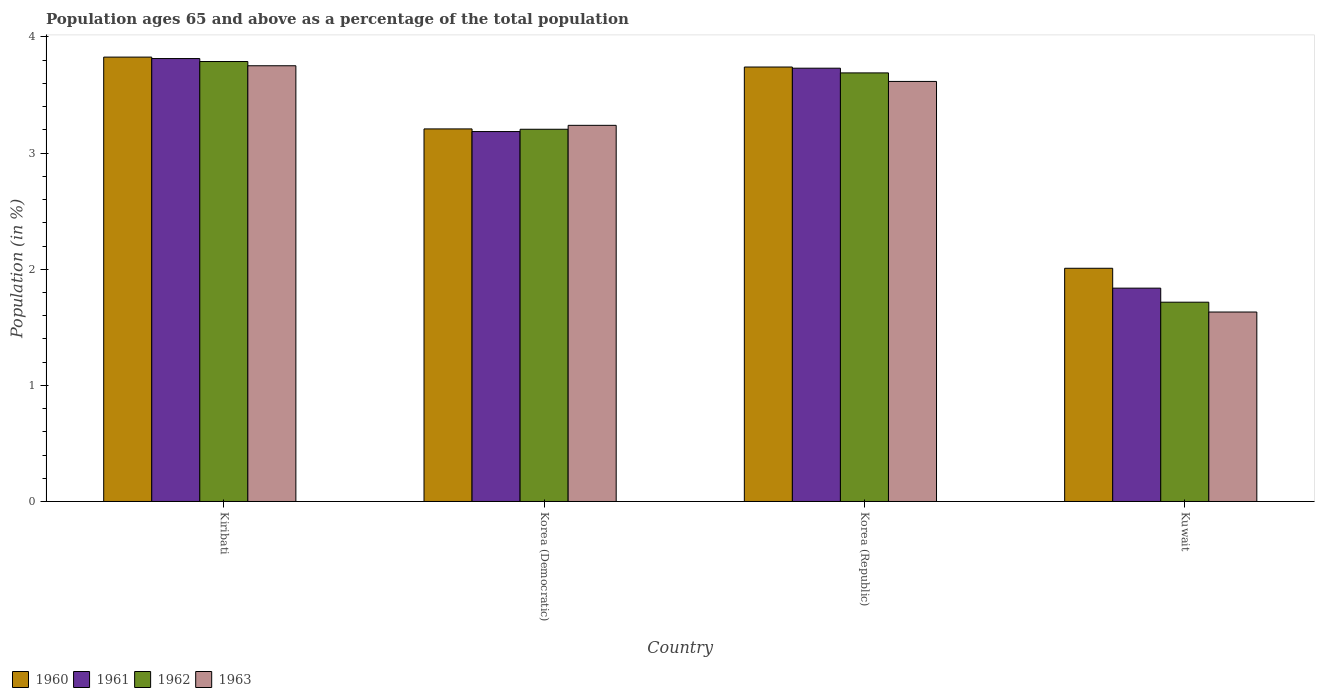How many groups of bars are there?
Ensure brevity in your answer.  4. Are the number of bars on each tick of the X-axis equal?
Ensure brevity in your answer.  Yes. How many bars are there on the 4th tick from the left?
Ensure brevity in your answer.  4. What is the label of the 2nd group of bars from the left?
Make the answer very short. Korea (Democratic). What is the percentage of the population ages 65 and above in 1963 in Korea (Democratic)?
Make the answer very short. 3.24. Across all countries, what is the maximum percentage of the population ages 65 and above in 1963?
Ensure brevity in your answer.  3.75. Across all countries, what is the minimum percentage of the population ages 65 and above in 1961?
Give a very brief answer. 1.84. In which country was the percentage of the population ages 65 and above in 1961 maximum?
Provide a succinct answer. Kiribati. In which country was the percentage of the population ages 65 and above in 1962 minimum?
Give a very brief answer. Kuwait. What is the total percentage of the population ages 65 and above in 1963 in the graph?
Your answer should be compact. 12.24. What is the difference between the percentage of the population ages 65 and above in 1963 in Korea (Republic) and that in Kuwait?
Provide a short and direct response. 1.99. What is the difference between the percentage of the population ages 65 and above in 1962 in Korea (Democratic) and the percentage of the population ages 65 and above in 1960 in Kuwait?
Keep it short and to the point. 1.2. What is the average percentage of the population ages 65 and above in 1962 per country?
Give a very brief answer. 3.1. What is the difference between the percentage of the population ages 65 and above of/in 1963 and percentage of the population ages 65 and above of/in 1961 in Kuwait?
Provide a succinct answer. -0.21. In how many countries, is the percentage of the population ages 65 and above in 1962 greater than 3.8?
Keep it short and to the point. 0. What is the ratio of the percentage of the population ages 65 and above in 1962 in Kiribati to that in Kuwait?
Your response must be concise. 2.21. Is the percentage of the population ages 65 and above in 1960 in Korea (Democratic) less than that in Korea (Republic)?
Offer a very short reply. Yes. Is the difference between the percentage of the population ages 65 and above in 1963 in Korea (Democratic) and Korea (Republic) greater than the difference between the percentage of the population ages 65 and above in 1961 in Korea (Democratic) and Korea (Republic)?
Your answer should be compact. Yes. What is the difference between the highest and the second highest percentage of the population ages 65 and above in 1961?
Provide a succinct answer. 0.55. What is the difference between the highest and the lowest percentage of the population ages 65 and above in 1961?
Offer a terse response. 1.98. Is the sum of the percentage of the population ages 65 and above in 1963 in Kiribati and Korea (Democratic) greater than the maximum percentage of the population ages 65 and above in 1960 across all countries?
Give a very brief answer. Yes. What does the 1st bar from the right in Korea (Republic) represents?
Offer a very short reply. 1963. Is it the case that in every country, the sum of the percentage of the population ages 65 and above in 1960 and percentage of the population ages 65 and above in 1962 is greater than the percentage of the population ages 65 and above in 1961?
Your response must be concise. Yes. How many bars are there?
Provide a succinct answer. 16. Are all the bars in the graph horizontal?
Provide a short and direct response. No. How many countries are there in the graph?
Give a very brief answer. 4. What is the difference between two consecutive major ticks on the Y-axis?
Give a very brief answer. 1. Where does the legend appear in the graph?
Your answer should be very brief. Bottom left. How many legend labels are there?
Provide a short and direct response. 4. How are the legend labels stacked?
Provide a short and direct response. Horizontal. What is the title of the graph?
Ensure brevity in your answer.  Population ages 65 and above as a percentage of the total population. What is the label or title of the X-axis?
Provide a succinct answer. Country. What is the Population (in %) of 1960 in Kiribati?
Your response must be concise. 3.83. What is the Population (in %) of 1961 in Kiribati?
Your answer should be very brief. 3.81. What is the Population (in %) in 1962 in Kiribati?
Give a very brief answer. 3.79. What is the Population (in %) in 1963 in Kiribati?
Provide a short and direct response. 3.75. What is the Population (in %) in 1960 in Korea (Democratic)?
Your response must be concise. 3.21. What is the Population (in %) of 1961 in Korea (Democratic)?
Your answer should be very brief. 3.19. What is the Population (in %) in 1962 in Korea (Democratic)?
Keep it short and to the point. 3.21. What is the Population (in %) of 1963 in Korea (Democratic)?
Make the answer very short. 3.24. What is the Population (in %) of 1960 in Korea (Republic)?
Ensure brevity in your answer.  3.74. What is the Population (in %) in 1961 in Korea (Republic)?
Offer a very short reply. 3.73. What is the Population (in %) of 1962 in Korea (Republic)?
Keep it short and to the point. 3.69. What is the Population (in %) of 1963 in Korea (Republic)?
Provide a short and direct response. 3.62. What is the Population (in %) in 1960 in Kuwait?
Provide a succinct answer. 2.01. What is the Population (in %) in 1961 in Kuwait?
Your response must be concise. 1.84. What is the Population (in %) in 1962 in Kuwait?
Provide a short and direct response. 1.72. What is the Population (in %) in 1963 in Kuwait?
Keep it short and to the point. 1.63. Across all countries, what is the maximum Population (in %) of 1960?
Provide a succinct answer. 3.83. Across all countries, what is the maximum Population (in %) of 1961?
Provide a succinct answer. 3.81. Across all countries, what is the maximum Population (in %) in 1962?
Offer a very short reply. 3.79. Across all countries, what is the maximum Population (in %) in 1963?
Provide a succinct answer. 3.75. Across all countries, what is the minimum Population (in %) in 1960?
Offer a very short reply. 2.01. Across all countries, what is the minimum Population (in %) in 1961?
Ensure brevity in your answer.  1.84. Across all countries, what is the minimum Population (in %) in 1962?
Offer a very short reply. 1.72. Across all countries, what is the minimum Population (in %) of 1963?
Give a very brief answer. 1.63. What is the total Population (in %) of 1960 in the graph?
Your answer should be compact. 12.79. What is the total Population (in %) in 1961 in the graph?
Give a very brief answer. 12.57. What is the total Population (in %) in 1962 in the graph?
Ensure brevity in your answer.  12.4. What is the total Population (in %) in 1963 in the graph?
Offer a terse response. 12.24. What is the difference between the Population (in %) in 1960 in Kiribati and that in Korea (Democratic)?
Offer a very short reply. 0.62. What is the difference between the Population (in %) of 1961 in Kiribati and that in Korea (Democratic)?
Make the answer very short. 0.63. What is the difference between the Population (in %) in 1962 in Kiribati and that in Korea (Democratic)?
Your response must be concise. 0.58. What is the difference between the Population (in %) of 1963 in Kiribati and that in Korea (Democratic)?
Your answer should be very brief. 0.51. What is the difference between the Population (in %) in 1960 in Kiribati and that in Korea (Republic)?
Ensure brevity in your answer.  0.09. What is the difference between the Population (in %) of 1961 in Kiribati and that in Korea (Republic)?
Offer a very short reply. 0.08. What is the difference between the Population (in %) of 1962 in Kiribati and that in Korea (Republic)?
Make the answer very short. 0.1. What is the difference between the Population (in %) in 1963 in Kiribati and that in Korea (Republic)?
Offer a very short reply. 0.14. What is the difference between the Population (in %) of 1960 in Kiribati and that in Kuwait?
Offer a terse response. 1.82. What is the difference between the Population (in %) of 1961 in Kiribati and that in Kuwait?
Provide a short and direct response. 1.98. What is the difference between the Population (in %) in 1962 in Kiribati and that in Kuwait?
Your answer should be compact. 2.07. What is the difference between the Population (in %) of 1963 in Kiribati and that in Kuwait?
Your response must be concise. 2.12. What is the difference between the Population (in %) of 1960 in Korea (Democratic) and that in Korea (Republic)?
Your response must be concise. -0.53. What is the difference between the Population (in %) of 1961 in Korea (Democratic) and that in Korea (Republic)?
Offer a terse response. -0.55. What is the difference between the Population (in %) in 1962 in Korea (Democratic) and that in Korea (Republic)?
Provide a succinct answer. -0.49. What is the difference between the Population (in %) in 1963 in Korea (Democratic) and that in Korea (Republic)?
Provide a short and direct response. -0.38. What is the difference between the Population (in %) in 1960 in Korea (Democratic) and that in Kuwait?
Provide a short and direct response. 1.2. What is the difference between the Population (in %) in 1961 in Korea (Democratic) and that in Kuwait?
Provide a succinct answer. 1.35. What is the difference between the Population (in %) of 1962 in Korea (Democratic) and that in Kuwait?
Ensure brevity in your answer.  1.49. What is the difference between the Population (in %) of 1963 in Korea (Democratic) and that in Kuwait?
Offer a very short reply. 1.61. What is the difference between the Population (in %) of 1960 in Korea (Republic) and that in Kuwait?
Your response must be concise. 1.73. What is the difference between the Population (in %) in 1961 in Korea (Republic) and that in Kuwait?
Provide a short and direct response. 1.89. What is the difference between the Population (in %) in 1962 in Korea (Republic) and that in Kuwait?
Your response must be concise. 1.97. What is the difference between the Population (in %) of 1963 in Korea (Republic) and that in Kuwait?
Offer a terse response. 1.99. What is the difference between the Population (in %) of 1960 in Kiribati and the Population (in %) of 1961 in Korea (Democratic)?
Provide a succinct answer. 0.64. What is the difference between the Population (in %) in 1960 in Kiribati and the Population (in %) in 1962 in Korea (Democratic)?
Provide a short and direct response. 0.62. What is the difference between the Population (in %) of 1960 in Kiribati and the Population (in %) of 1963 in Korea (Democratic)?
Provide a short and direct response. 0.59. What is the difference between the Population (in %) in 1961 in Kiribati and the Population (in %) in 1962 in Korea (Democratic)?
Your answer should be compact. 0.61. What is the difference between the Population (in %) in 1961 in Kiribati and the Population (in %) in 1963 in Korea (Democratic)?
Offer a very short reply. 0.58. What is the difference between the Population (in %) of 1962 in Kiribati and the Population (in %) of 1963 in Korea (Democratic)?
Give a very brief answer. 0.55. What is the difference between the Population (in %) in 1960 in Kiribati and the Population (in %) in 1961 in Korea (Republic)?
Make the answer very short. 0.1. What is the difference between the Population (in %) of 1960 in Kiribati and the Population (in %) of 1962 in Korea (Republic)?
Make the answer very short. 0.14. What is the difference between the Population (in %) of 1960 in Kiribati and the Population (in %) of 1963 in Korea (Republic)?
Provide a succinct answer. 0.21. What is the difference between the Population (in %) of 1961 in Kiribati and the Population (in %) of 1962 in Korea (Republic)?
Ensure brevity in your answer.  0.12. What is the difference between the Population (in %) in 1961 in Kiribati and the Population (in %) in 1963 in Korea (Republic)?
Make the answer very short. 0.2. What is the difference between the Population (in %) in 1962 in Kiribati and the Population (in %) in 1963 in Korea (Republic)?
Your answer should be very brief. 0.17. What is the difference between the Population (in %) in 1960 in Kiribati and the Population (in %) in 1961 in Kuwait?
Provide a short and direct response. 1.99. What is the difference between the Population (in %) in 1960 in Kiribati and the Population (in %) in 1962 in Kuwait?
Your response must be concise. 2.11. What is the difference between the Population (in %) of 1960 in Kiribati and the Population (in %) of 1963 in Kuwait?
Your answer should be compact. 2.2. What is the difference between the Population (in %) of 1961 in Kiribati and the Population (in %) of 1962 in Kuwait?
Provide a succinct answer. 2.1. What is the difference between the Population (in %) in 1961 in Kiribati and the Population (in %) in 1963 in Kuwait?
Ensure brevity in your answer.  2.18. What is the difference between the Population (in %) in 1962 in Kiribati and the Population (in %) in 1963 in Kuwait?
Ensure brevity in your answer.  2.16. What is the difference between the Population (in %) of 1960 in Korea (Democratic) and the Population (in %) of 1961 in Korea (Republic)?
Make the answer very short. -0.52. What is the difference between the Population (in %) in 1960 in Korea (Democratic) and the Population (in %) in 1962 in Korea (Republic)?
Your response must be concise. -0.48. What is the difference between the Population (in %) of 1960 in Korea (Democratic) and the Population (in %) of 1963 in Korea (Republic)?
Provide a succinct answer. -0.41. What is the difference between the Population (in %) in 1961 in Korea (Democratic) and the Population (in %) in 1962 in Korea (Republic)?
Offer a very short reply. -0.51. What is the difference between the Population (in %) in 1961 in Korea (Democratic) and the Population (in %) in 1963 in Korea (Republic)?
Provide a succinct answer. -0.43. What is the difference between the Population (in %) of 1962 in Korea (Democratic) and the Population (in %) of 1963 in Korea (Republic)?
Provide a succinct answer. -0.41. What is the difference between the Population (in %) of 1960 in Korea (Democratic) and the Population (in %) of 1961 in Kuwait?
Offer a terse response. 1.37. What is the difference between the Population (in %) in 1960 in Korea (Democratic) and the Population (in %) in 1962 in Kuwait?
Ensure brevity in your answer.  1.49. What is the difference between the Population (in %) of 1960 in Korea (Democratic) and the Population (in %) of 1963 in Kuwait?
Your response must be concise. 1.58. What is the difference between the Population (in %) in 1961 in Korea (Democratic) and the Population (in %) in 1962 in Kuwait?
Keep it short and to the point. 1.47. What is the difference between the Population (in %) in 1961 in Korea (Democratic) and the Population (in %) in 1963 in Kuwait?
Make the answer very short. 1.55. What is the difference between the Population (in %) of 1962 in Korea (Democratic) and the Population (in %) of 1963 in Kuwait?
Keep it short and to the point. 1.57. What is the difference between the Population (in %) of 1960 in Korea (Republic) and the Population (in %) of 1961 in Kuwait?
Offer a terse response. 1.9. What is the difference between the Population (in %) in 1960 in Korea (Republic) and the Population (in %) in 1962 in Kuwait?
Your answer should be compact. 2.03. What is the difference between the Population (in %) of 1960 in Korea (Republic) and the Population (in %) of 1963 in Kuwait?
Offer a terse response. 2.11. What is the difference between the Population (in %) in 1961 in Korea (Republic) and the Population (in %) in 1962 in Kuwait?
Ensure brevity in your answer.  2.02. What is the difference between the Population (in %) of 1961 in Korea (Republic) and the Population (in %) of 1963 in Kuwait?
Keep it short and to the point. 2.1. What is the difference between the Population (in %) in 1962 in Korea (Republic) and the Population (in %) in 1963 in Kuwait?
Give a very brief answer. 2.06. What is the average Population (in %) of 1960 per country?
Give a very brief answer. 3.2. What is the average Population (in %) in 1961 per country?
Make the answer very short. 3.14. What is the average Population (in %) in 1962 per country?
Offer a terse response. 3.1. What is the average Population (in %) of 1963 per country?
Provide a succinct answer. 3.06. What is the difference between the Population (in %) in 1960 and Population (in %) in 1961 in Kiribati?
Your answer should be compact. 0.01. What is the difference between the Population (in %) in 1960 and Population (in %) in 1962 in Kiribati?
Your answer should be compact. 0.04. What is the difference between the Population (in %) of 1960 and Population (in %) of 1963 in Kiribati?
Your response must be concise. 0.07. What is the difference between the Population (in %) in 1961 and Population (in %) in 1962 in Kiribati?
Ensure brevity in your answer.  0.03. What is the difference between the Population (in %) of 1961 and Population (in %) of 1963 in Kiribati?
Keep it short and to the point. 0.06. What is the difference between the Population (in %) in 1962 and Population (in %) in 1963 in Kiribati?
Ensure brevity in your answer.  0.04. What is the difference between the Population (in %) in 1960 and Population (in %) in 1961 in Korea (Democratic)?
Your answer should be very brief. 0.02. What is the difference between the Population (in %) in 1960 and Population (in %) in 1962 in Korea (Democratic)?
Ensure brevity in your answer.  0. What is the difference between the Population (in %) of 1960 and Population (in %) of 1963 in Korea (Democratic)?
Keep it short and to the point. -0.03. What is the difference between the Population (in %) in 1961 and Population (in %) in 1962 in Korea (Democratic)?
Make the answer very short. -0.02. What is the difference between the Population (in %) in 1961 and Population (in %) in 1963 in Korea (Democratic)?
Offer a terse response. -0.05. What is the difference between the Population (in %) in 1962 and Population (in %) in 1963 in Korea (Democratic)?
Offer a very short reply. -0.03. What is the difference between the Population (in %) of 1960 and Population (in %) of 1961 in Korea (Republic)?
Offer a terse response. 0.01. What is the difference between the Population (in %) in 1960 and Population (in %) in 1962 in Korea (Republic)?
Ensure brevity in your answer.  0.05. What is the difference between the Population (in %) in 1960 and Population (in %) in 1963 in Korea (Republic)?
Offer a very short reply. 0.12. What is the difference between the Population (in %) of 1961 and Population (in %) of 1962 in Korea (Republic)?
Provide a short and direct response. 0.04. What is the difference between the Population (in %) of 1961 and Population (in %) of 1963 in Korea (Republic)?
Offer a very short reply. 0.11. What is the difference between the Population (in %) of 1962 and Population (in %) of 1963 in Korea (Republic)?
Provide a short and direct response. 0.07. What is the difference between the Population (in %) of 1960 and Population (in %) of 1961 in Kuwait?
Your answer should be compact. 0.17. What is the difference between the Population (in %) in 1960 and Population (in %) in 1962 in Kuwait?
Make the answer very short. 0.29. What is the difference between the Population (in %) in 1960 and Population (in %) in 1963 in Kuwait?
Your answer should be compact. 0.38. What is the difference between the Population (in %) of 1961 and Population (in %) of 1962 in Kuwait?
Your response must be concise. 0.12. What is the difference between the Population (in %) of 1961 and Population (in %) of 1963 in Kuwait?
Offer a very short reply. 0.21. What is the difference between the Population (in %) of 1962 and Population (in %) of 1963 in Kuwait?
Keep it short and to the point. 0.08. What is the ratio of the Population (in %) in 1960 in Kiribati to that in Korea (Democratic)?
Make the answer very short. 1.19. What is the ratio of the Population (in %) of 1961 in Kiribati to that in Korea (Democratic)?
Offer a terse response. 1.2. What is the ratio of the Population (in %) of 1962 in Kiribati to that in Korea (Democratic)?
Offer a very short reply. 1.18. What is the ratio of the Population (in %) of 1963 in Kiribati to that in Korea (Democratic)?
Your answer should be compact. 1.16. What is the ratio of the Population (in %) in 1960 in Kiribati to that in Korea (Republic)?
Ensure brevity in your answer.  1.02. What is the ratio of the Population (in %) in 1961 in Kiribati to that in Korea (Republic)?
Make the answer very short. 1.02. What is the ratio of the Population (in %) of 1962 in Kiribati to that in Korea (Republic)?
Give a very brief answer. 1.03. What is the ratio of the Population (in %) of 1963 in Kiribati to that in Korea (Republic)?
Your answer should be very brief. 1.04. What is the ratio of the Population (in %) in 1960 in Kiribati to that in Kuwait?
Your response must be concise. 1.91. What is the ratio of the Population (in %) in 1961 in Kiribati to that in Kuwait?
Your response must be concise. 2.08. What is the ratio of the Population (in %) in 1962 in Kiribati to that in Kuwait?
Give a very brief answer. 2.21. What is the ratio of the Population (in %) of 1963 in Kiribati to that in Kuwait?
Your answer should be compact. 2.3. What is the ratio of the Population (in %) of 1960 in Korea (Democratic) to that in Korea (Republic)?
Your response must be concise. 0.86. What is the ratio of the Population (in %) in 1961 in Korea (Democratic) to that in Korea (Republic)?
Your response must be concise. 0.85. What is the ratio of the Population (in %) of 1962 in Korea (Democratic) to that in Korea (Republic)?
Provide a short and direct response. 0.87. What is the ratio of the Population (in %) in 1963 in Korea (Democratic) to that in Korea (Republic)?
Your answer should be very brief. 0.9. What is the ratio of the Population (in %) of 1960 in Korea (Democratic) to that in Kuwait?
Provide a short and direct response. 1.6. What is the ratio of the Population (in %) in 1961 in Korea (Democratic) to that in Kuwait?
Give a very brief answer. 1.73. What is the ratio of the Population (in %) in 1962 in Korea (Democratic) to that in Kuwait?
Make the answer very short. 1.87. What is the ratio of the Population (in %) of 1963 in Korea (Democratic) to that in Kuwait?
Keep it short and to the point. 1.99. What is the ratio of the Population (in %) of 1960 in Korea (Republic) to that in Kuwait?
Provide a succinct answer. 1.86. What is the ratio of the Population (in %) of 1961 in Korea (Republic) to that in Kuwait?
Offer a terse response. 2.03. What is the ratio of the Population (in %) of 1962 in Korea (Republic) to that in Kuwait?
Provide a succinct answer. 2.15. What is the ratio of the Population (in %) of 1963 in Korea (Republic) to that in Kuwait?
Keep it short and to the point. 2.22. What is the difference between the highest and the second highest Population (in %) in 1960?
Offer a very short reply. 0.09. What is the difference between the highest and the second highest Population (in %) in 1961?
Your response must be concise. 0.08. What is the difference between the highest and the second highest Population (in %) in 1962?
Your answer should be very brief. 0.1. What is the difference between the highest and the second highest Population (in %) of 1963?
Your answer should be very brief. 0.14. What is the difference between the highest and the lowest Population (in %) of 1960?
Ensure brevity in your answer.  1.82. What is the difference between the highest and the lowest Population (in %) of 1961?
Provide a succinct answer. 1.98. What is the difference between the highest and the lowest Population (in %) of 1962?
Offer a very short reply. 2.07. What is the difference between the highest and the lowest Population (in %) in 1963?
Make the answer very short. 2.12. 